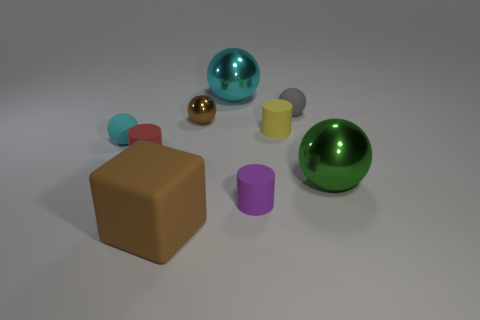Subtract 2 spheres. How many spheres are left? 3 Subtract all large cyan metal spheres. How many spheres are left? 4 Subtract all gray balls. How many balls are left? 4 Subtract all purple spheres. Subtract all red cylinders. How many spheres are left? 5 Add 1 large cyan things. How many objects exist? 10 Subtract all spheres. How many objects are left? 4 Subtract 0 red balls. How many objects are left? 9 Subtract all small purple cylinders. Subtract all brown spheres. How many objects are left? 7 Add 2 small brown metallic balls. How many small brown metallic balls are left? 3 Add 5 small red cylinders. How many small red cylinders exist? 6 